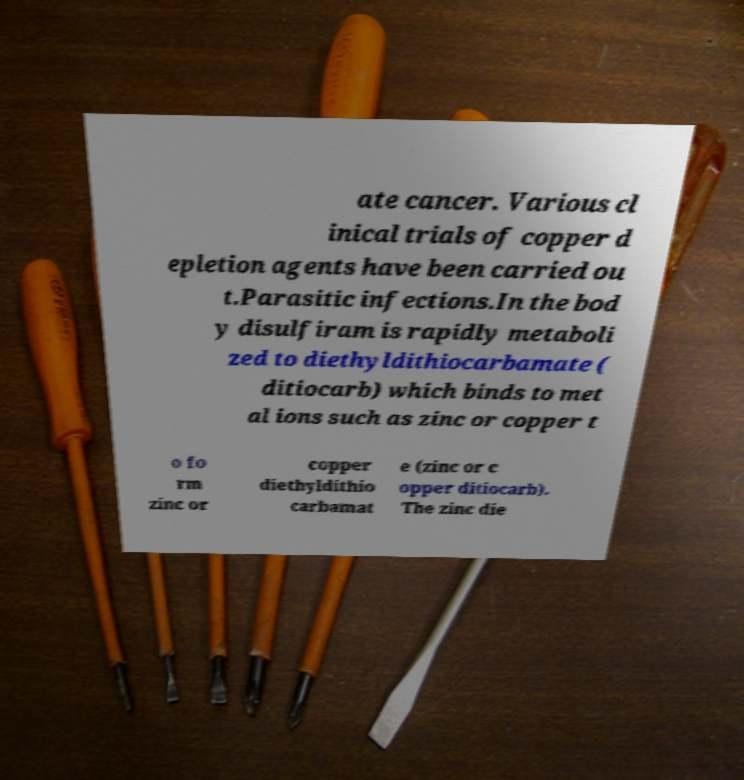Please read and relay the text visible in this image. What does it say? ate cancer. Various cl inical trials of copper d epletion agents have been carried ou t.Parasitic infections.In the bod y disulfiram is rapidly metaboli zed to diethyldithiocarbamate ( ditiocarb) which binds to met al ions such as zinc or copper t o fo rm zinc or copper diethyldithio carbamat e (zinc or c opper ditiocarb). The zinc die 